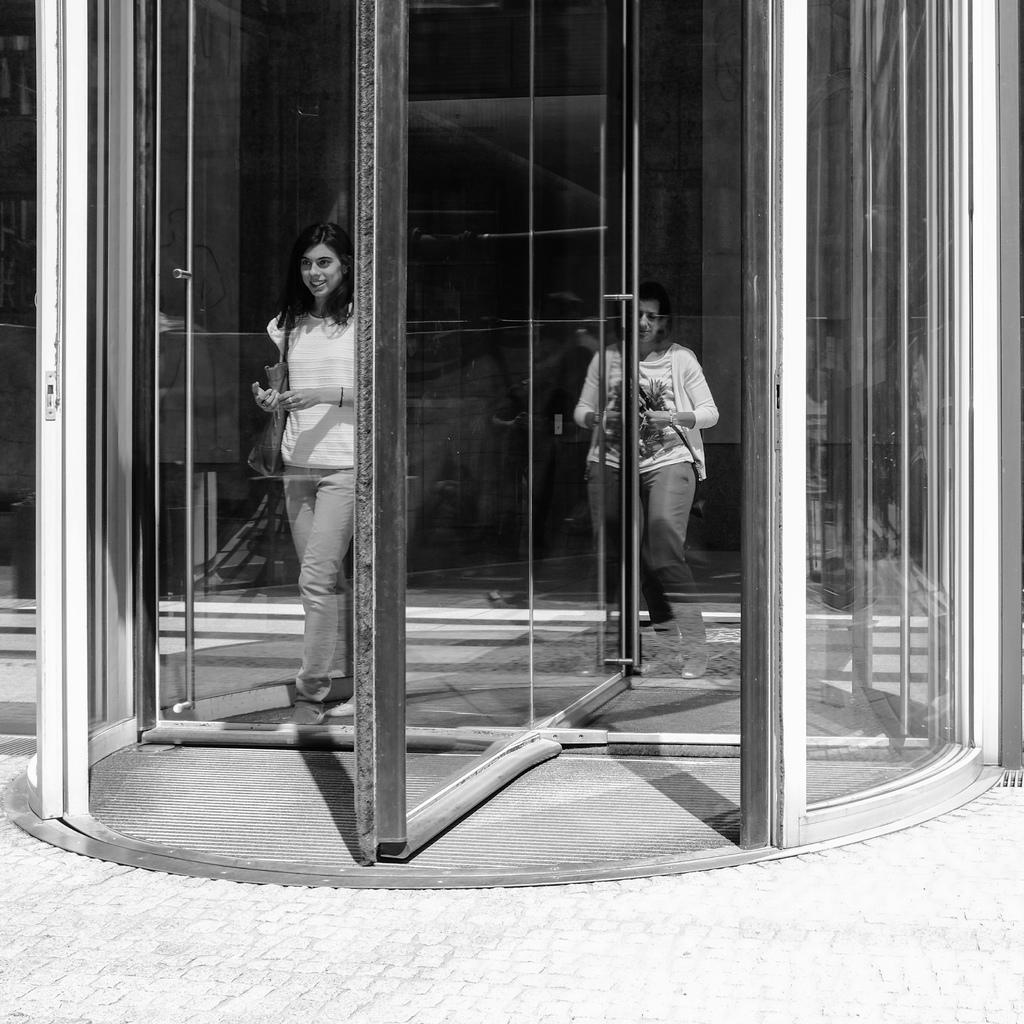What are the two persons in the image doing? The two persons in the image are walking. What type of door can be seen in the image? There is a glass door in the image. What is the color scheme of the image? The image is in black and white. Can you see a monkey playing with a camp in the image? No, there is no monkey or camp present in the image. What type of metal is the copper door in the image made of? There is no copper door in the image; it is a glass door. 